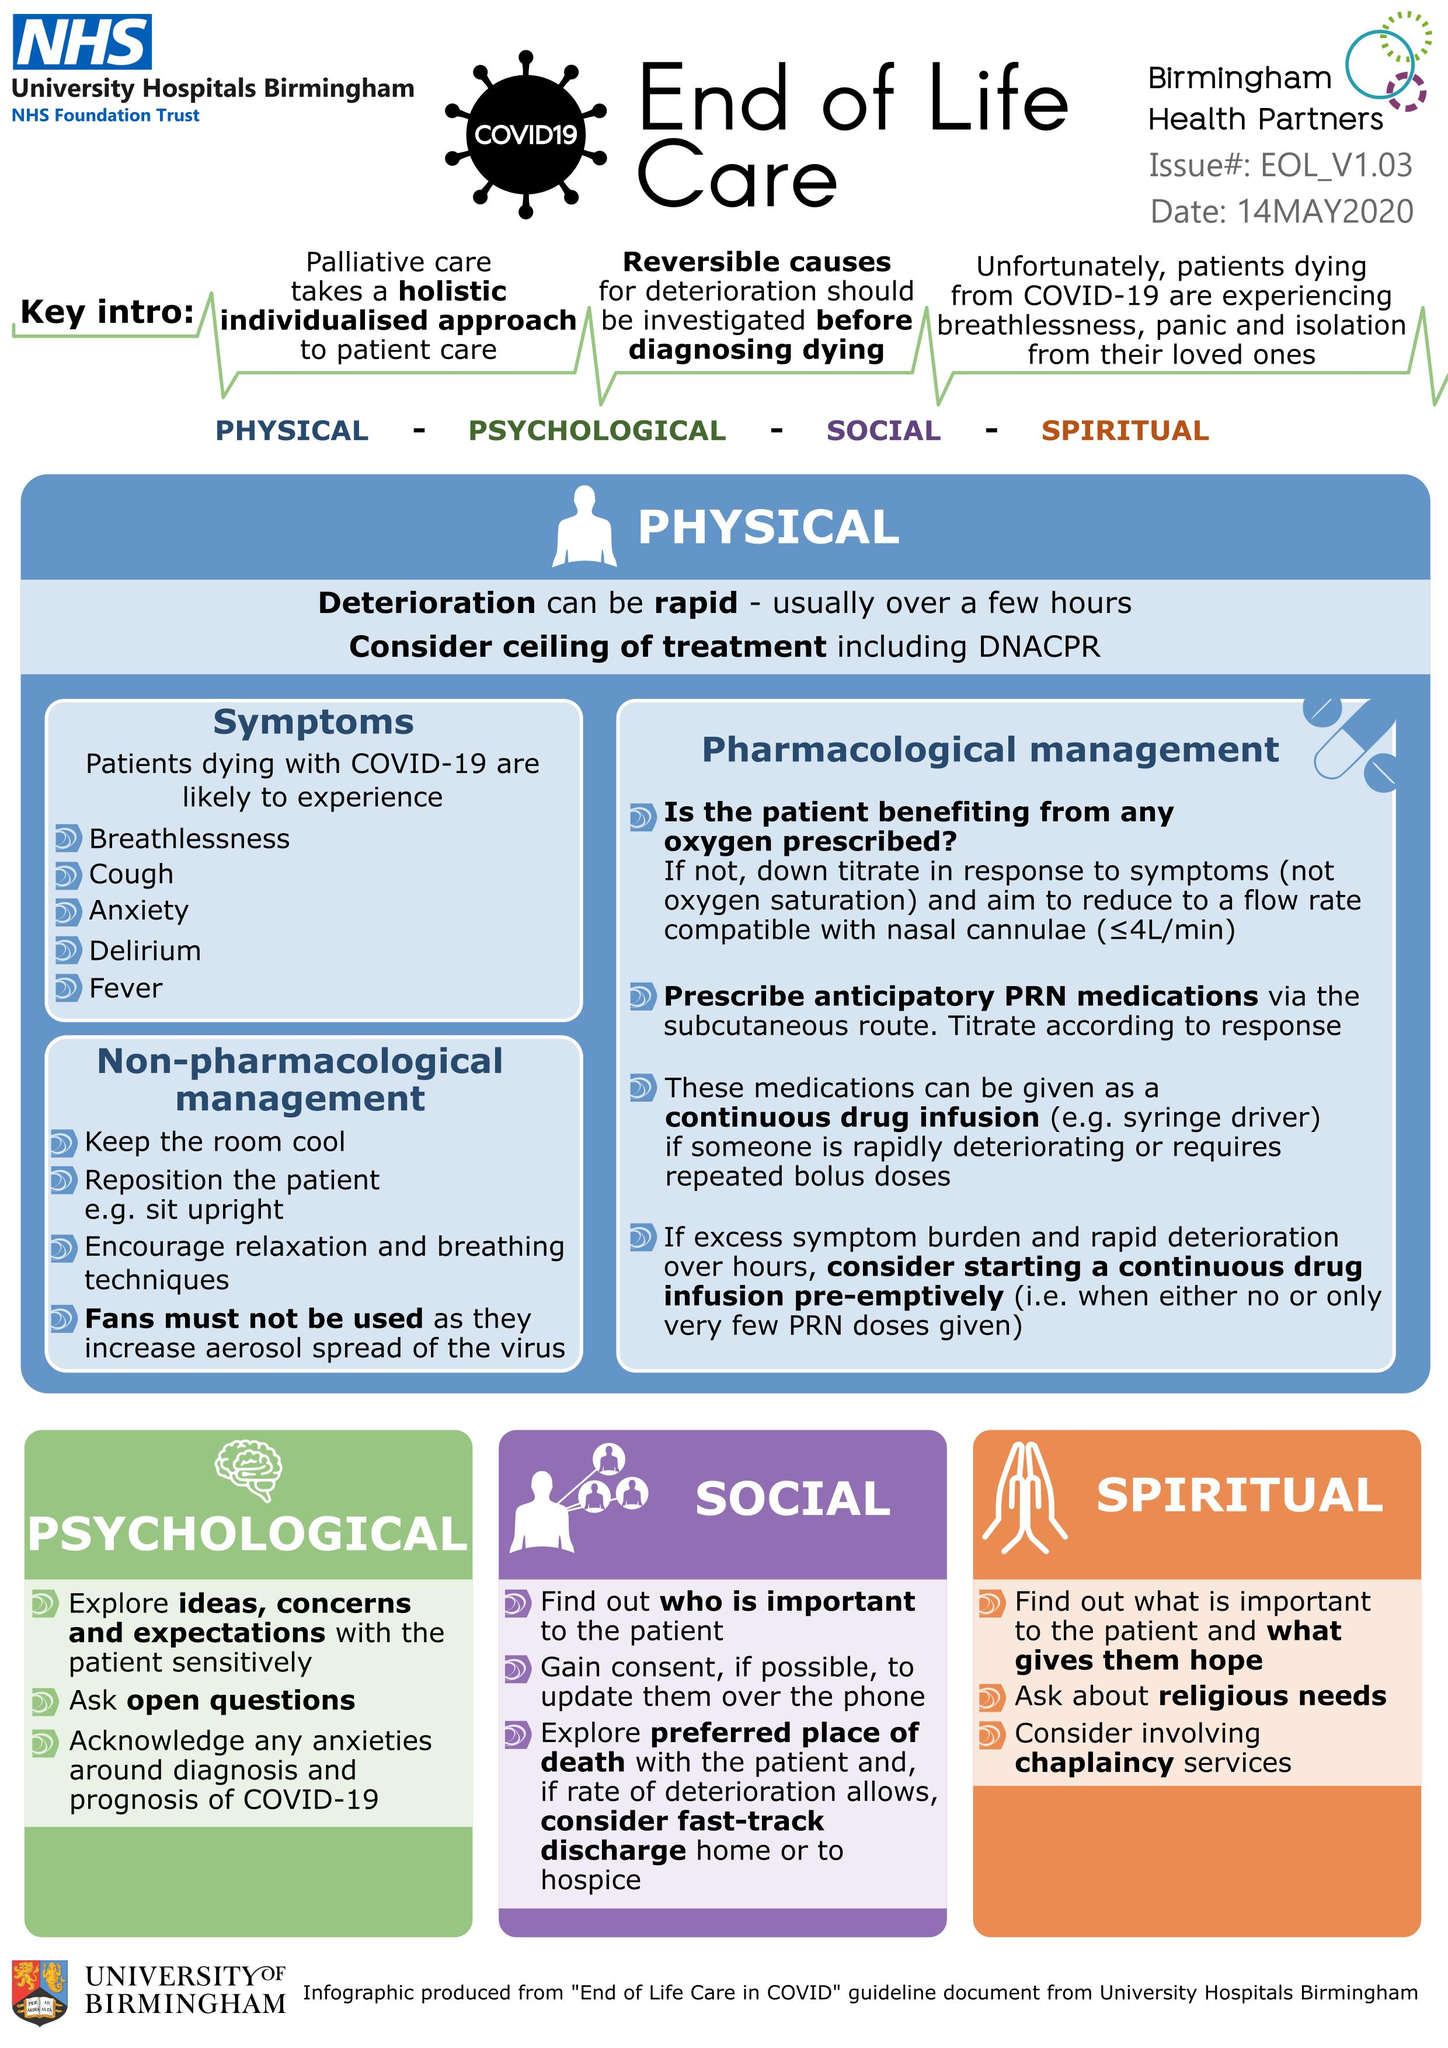Outline some significant characteristics in this image. The increased use of air conditioning fans is believed to have contributed to the aerosol spread of the virus. It is important to investigate the cause of death before making a diagnosis, particularly in cases where the patient's condition has deteriorated. Reversible causes must be considered as potential causes of the deterioration. Non-pharmacological management, specifically the act of keeping the room cool, is an essential aspect of physical treatment for maintaining a comfortable environment for patients. Open questions are typically asked in psychological treatments. Four treatments are currently being considered in end-of-life care. 